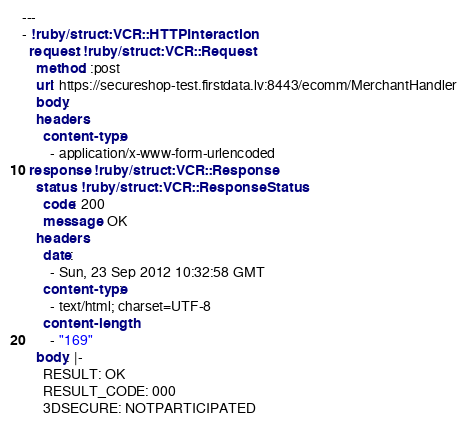Convert code to text. <code><loc_0><loc_0><loc_500><loc_500><_YAML_>--- 
- !ruby/struct:VCR::HTTPInteraction 
  request: !ruby/struct:VCR::Request 
    method: :post
    uri: https://secureshop-test.firstdata.lv:8443/ecomm/MerchantHandler
    body: 
    headers: 
      content-type: 
        - application/x-www-form-urlencoded
  response: !ruby/struct:VCR::Response 
    status: !ruby/struct:VCR::ResponseStatus 
      code: 200
      message: OK
    headers: 
      date: 
        - Sun, 23 Sep 2012 10:32:58 GMT
      content-type: 
        - text/html; charset=UTF-8
      content-length: 
        - "169"
    body: |-
      RESULT: OK
      RESULT_CODE: 000
      3DSECURE: NOTPARTICIPATED</code> 